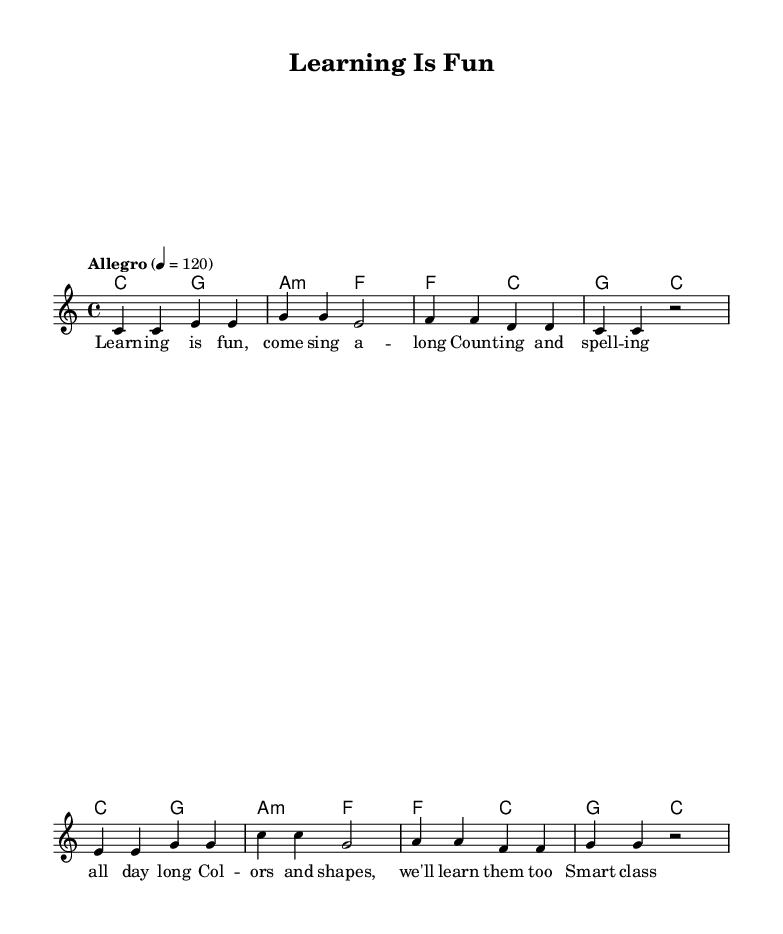What is the key signature of this music? The key signature is indicated as C major, which is shown at the beginning of the score. C major has no sharps or flats.
Answer: C major What is the time signature of the piece? The time signature is located at the beginning of the score, and it is written as 4/4, meaning there are four beats in each measure and the quarter note gets one beat.
Answer: 4/4 What is the tempo marking for the music? The tempo marking is found in the header and specifies the speed of the piece as "Allegro" with a metronome marking of 120 beats per minute.
Answer: Allegro How many measures are in the melody? By counting the measure lines in the melody section, there are a total of eight measures.
Answer: Eight Which sections of the music include lyrics? The lyrics are specifically under the "verse" section and are connected to the melody throughout all measures of the piece, reflecting the learning theme.
Answer: Verse What is the primary focus of the lyrics? The lyrics emphasize learning and education, showcasing activities like counting, spelling, and recognizing colors and shapes, which are suitable for children.
Answer: Learning What is the relationship between the chords and the melody? The chords provided in the harmonies section support the melody notes by establishing the harmonic context and enriching the musical experience in the key of C major.
Answer: Support 